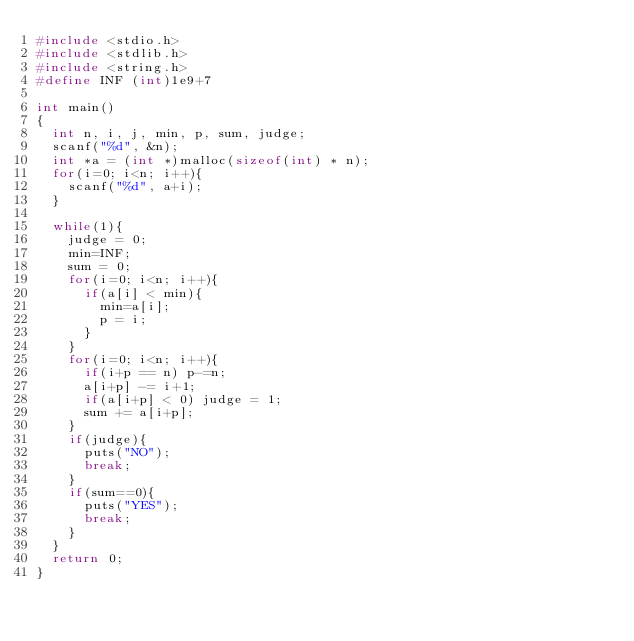<code> <loc_0><loc_0><loc_500><loc_500><_C_>#include <stdio.h>
#include <stdlib.h>
#include <string.h>
#define INF (int)1e9+7

int main()
{
  int n, i, j, min, p, sum, judge;
  scanf("%d", &n);
  int *a = (int *)malloc(sizeof(int) * n);
  for(i=0; i<n; i++){
    scanf("%d", a+i);
  }

  while(1){
    judge = 0;
    min=INF;
    sum = 0;
    for(i=0; i<n; i++){
      if(a[i] < min){
        min=a[i];
        p = i;
      }
    }
    for(i=0; i<n; i++){
      if(i+p == n) p-=n;
      a[i+p] -= i+1;
      if(a[i+p] < 0) judge = 1;
      sum += a[i+p];
    }
    if(judge){
      puts("NO");
      break;
    }
    if(sum==0){
      puts("YES");
      break;
    }
  }
  return 0;
}</code> 